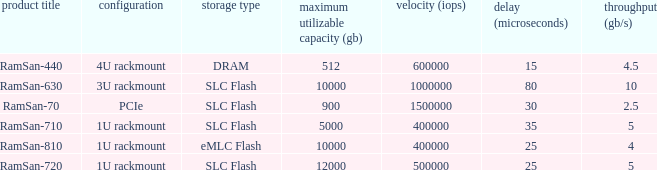What is the ramsan-810 transfer delay? 1.0. 